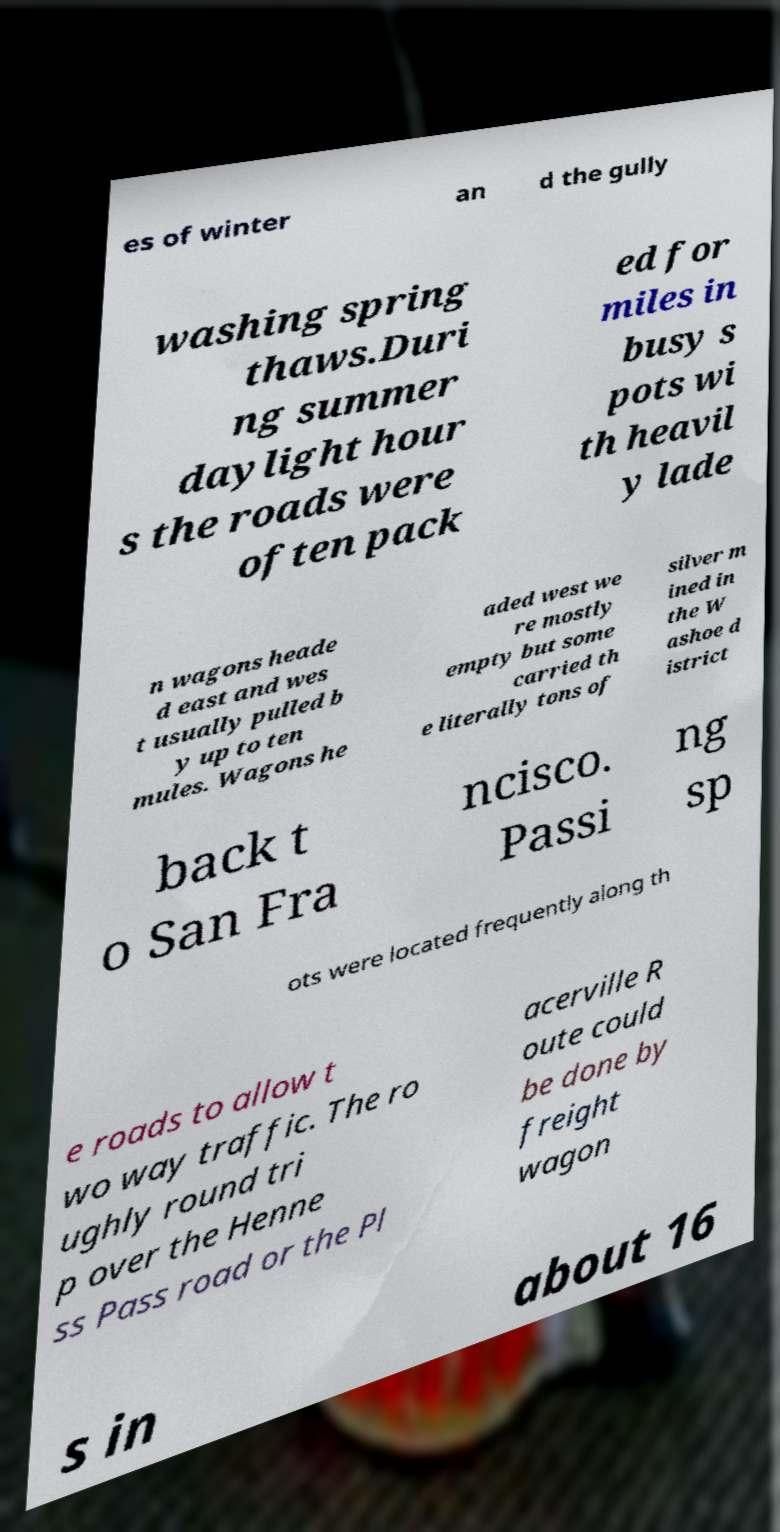I need the written content from this picture converted into text. Can you do that? es of winter an d the gully washing spring thaws.Duri ng summer daylight hour s the roads were often pack ed for miles in busy s pots wi th heavil y lade n wagons heade d east and wes t usually pulled b y up to ten mules. Wagons he aded west we re mostly empty but some carried th e literally tons of silver m ined in the W ashoe d istrict back t o San Fra ncisco. Passi ng sp ots were located frequently along th e roads to allow t wo way traffic. The ro ughly round tri p over the Henne ss Pass road or the Pl acerville R oute could be done by freight wagon s in about 16 